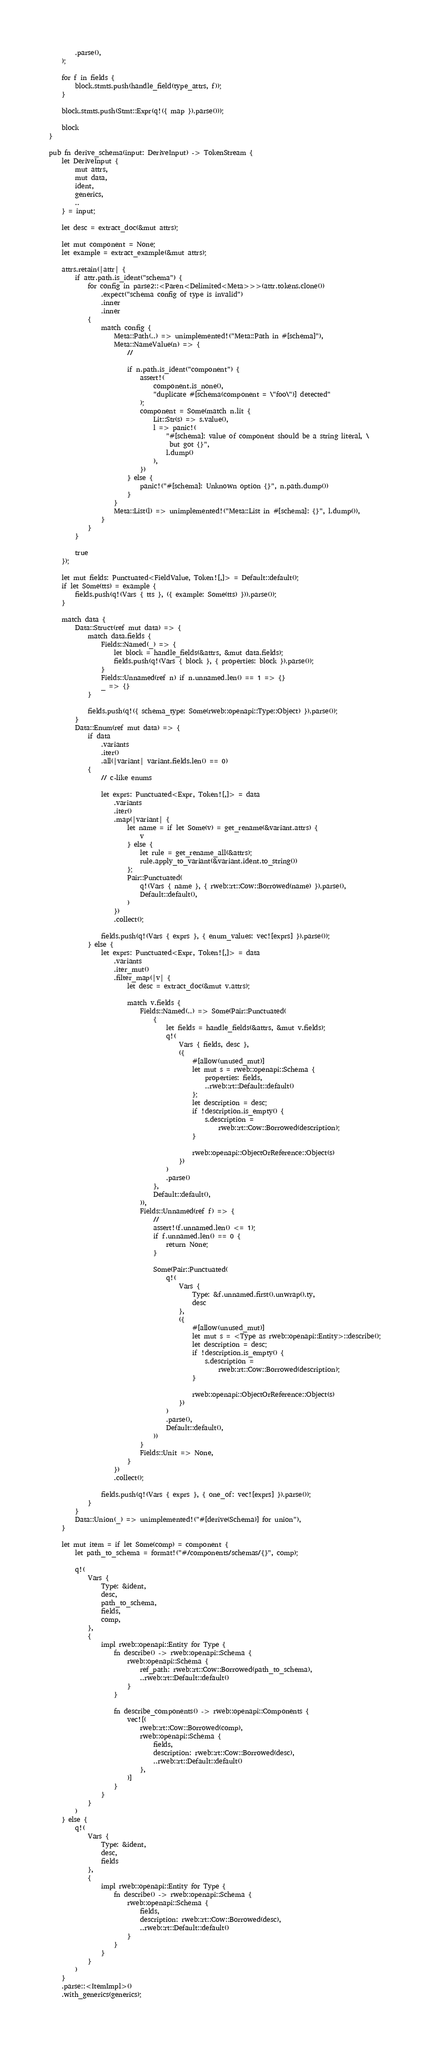<code> <loc_0><loc_0><loc_500><loc_500><_Rust_>        .parse(),
    );

    for f in fields {
        block.stmts.push(handle_field(type_attrs, f));
    }

    block.stmts.push(Stmt::Expr(q!({ map }).parse()));

    block
}

pub fn derive_schema(input: DeriveInput) -> TokenStream {
    let DeriveInput {
        mut attrs,
        mut data,
        ident,
        generics,
        ..
    } = input;

    let desc = extract_doc(&mut attrs);

    let mut component = None;
    let example = extract_example(&mut attrs);

    attrs.retain(|attr| {
        if attr.path.is_ident("schema") {
            for config in parse2::<Paren<Delimited<Meta>>>(attr.tokens.clone())
                .expect("schema config of type is invalid")
                .inner
                .inner
            {
                match config {
                    Meta::Path(..) => unimplemented!("Meta::Path in #[schema]"),
                    Meta::NameValue(n) => {
                        //

                        if n.path.is_ident("component") {
                            assert!(
                                component.is_none(),
                                "duplicate #[schema(component = \"foo\")] detected"
                            );
                            component = Some(match n.lit {
                                Lit::Str(s) => s.value(),
                                l => panic!(
                                    "#[schema]: value of component should be a string literal, \
                                     but got {}",
                                    l.dump()
                                ),
                            })
                        } else {
                            panic!("#[schema]: Unknown option {}", n.path.dump())
                        }
                    }
                    Meta::List(l) => unimplemented!("Meta::List in #[schema]: {}", l.dump()),
                }
            }
        }

        true
    });

    let mut fields: Punctuated<FieldValue, Token![,]> = Default::default();
    if let Some(tts) = example {
        fields.push(q!(Vars { tts }, ({ example: Some(tts) })).parse());
    }

    match data {
        Data::Struct(ref mut data) => {
            match data.fields {
                Fields::Named(_) => {
                    let block = handle_fields(&attrs, &mut data.fields);
                    fields.push(q!(Vars { block }, { properties: block }).parse());
                }
                Fields::Unnamed(ref n) if n.unnamed.len() == 1 => {}
                _ => {}
            }

            fields.push(q!({ schema_type: Some(rweb::openapi::Type::Object) }).parse());
        }
        Data::Enum(ref mut data) => {
            if data
                .variants
                .iter()
                .all(|variant| variant.fields.len() == 0)
            {
                // c-like enums

                let exprs: Punctuated<Expr, Token![,]> = data
                    .variants
                    .iter()
                    .map(|variant| {
                        let name = if let Some(v) = get_rename(&variant.attrs) {
                            v
                        } else {
                            let rule = get_rename_all(&attrs);
                            rule.apply_to_variant(&variant.ident.to_string())
                        };
                        Pair::Punctuated(
                            q!(Vars { name }, { rweb::rt::Cow::Borrowed(name) }).parse(),
                            Default::default(),
                        )
                    })
                    .collect();

                fields.push(q!(Vars { exprs }, { enum_values: vec![exprs] }).parse());
            } else {
                let exprs: Punctuated<Expr, Token![,]> = data
                    .variants
                    .iter_mut()
                    .filter_map(|v| {
                        let desc = extract_doc(&mut v.attrs);

                        match v.fields {
                            Fields::Named(..) => Some(Pair::Punctuated(
                                {
                                    let fields = handle_fields(&attrs, &mut v.fields);
                                    q!(
                                        Vars { fields, desc },
                                        ({
                                            #[allow(unused_mut)]
                                            let mut s = rweb::openapi::Schema {
                                                properties: fields,
                                                ..rweb::rt::Default::default()
                                            };
                                            let description = desc;
                                            if !description.is_empty() {
                                                s.description =
                                                    rweb::rt::Cow::Borrowed(description);
                                            }

                                            rweb::openapi::ObjectOrReference::Object(s)
                                        })
                                    )
                                    .parse()
                                },
                                Default::default(),
                            )),
                            Fields::Unnamed(ref f) => {
                                //
                                assert!(f.unnamed.len() <= 1);
                                if f.unnamed.len() == 0 {
                                    return None;
                                }

                                Some(Pair::Punctuated(
                                    q!(
                                        Vars {
                                            Type: &f.unnamed.first().unwrap().ty,
                                            desc
                                        },
                                        ({
                                            #[allow(unused_mut)]
                                            let mut s = <Type as rweb::openapi::Entity>::describe();
                                            let description = desc;
                                            if !description.is_empty() {
                                                s.description =
                                                    rweb::rt::Cow::Borrowed(description);
                                            }

                                            rweb::openapi::ObjectOrReference::Object(s)
                                        })
                                    )
                                    .parse(),
                                    Default::default(),
                                ))
                            }
                            Fields::Unit => None,
                        }
                    })
                    .collect();

                fields.push(q!(Vars { exprs }, { one_of: vec![exprs] }).parse());
            }
        }
        Data::Union(_) => unimplemented!("#[derive(Schema)] for union"),
    }

    let mut item = if let Some(comp) = component {
        let path_to_schema = format!("#/components/schemas/{}", comp);

        q!(
            Vars {
                Type: &ident,
                desc,
                path_to_schema,
                fields,
                comp,
            },
            {
                impl rweb::openapi::Entity for Type {
                    fn describe() -> rweb::openapi::Schema {
                        rweb::openapi::Schema {
                            ref_path: rweb::rt::Cow::Borrowed(path_to_schema),
                            ..rweb::rt::Default::default()
                        }
                    }

                    fn describe_components() -> rweb::openapi::Components {
                        vec![(
                            rweb::rt::Cow::Borrowed(comp),
                            rweb::openapi::Schema {
                                fields,
                                description: rweb::rt::Cow::Borrowed(desc),
                                ..rweb::rt::Default::default()
                            },
                        )]
                    }
                }
            }
        )
    } else {
        q!(
            Vars {
                Type: &ident,
                desc,
                fields
            },
            {
                impl rweb::openapi::Entity for Type {
                    fn describe() -> rweb::openapi::Schema {
                        rweb::openapi::Schema {
                            fields,
                            description: rweb::rt::Cow::Borrowed(desc),
                            ..rweb::rt::Default::default()
                        }
                    }
                }
            }
        )
    }
    .parse::<ItemImpl>()
    .with_generics(generics);
</code> 